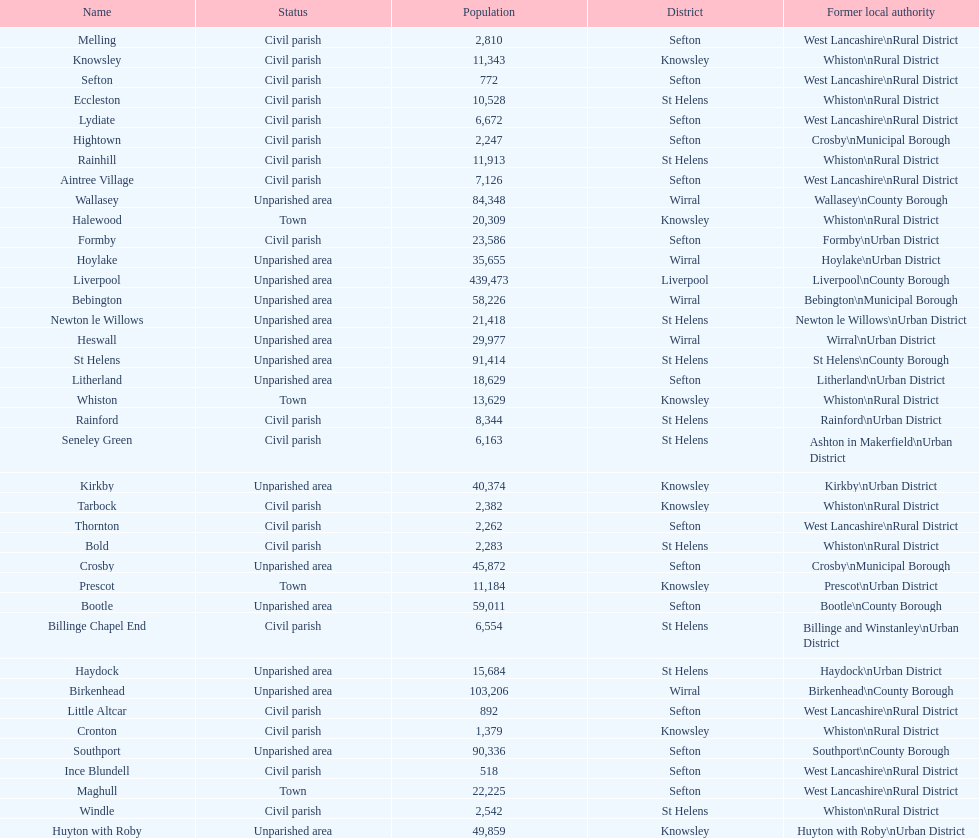How many people live in the bold civil parish? 2,283. 